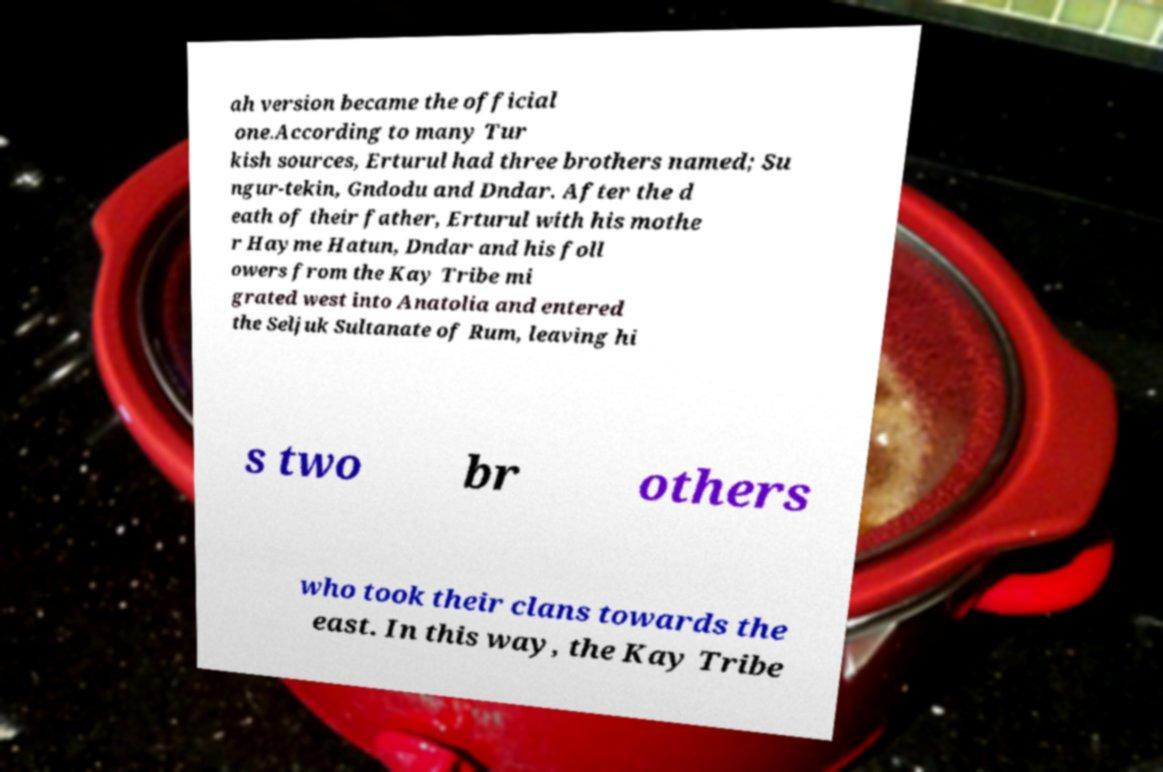Can you accurately transcribe the text from the provided image for me? ah version became the official one.According to many Tur kish sources, Erturul had three brothers named; Su ngur-tekin, Gndodu and Dndar. After the d eath of their father, Erturul with his mothe r Hayme Hatun, Dndar and his foll owers from the Kay Tribe mi grated west into Anatolia and entered the Seljuk Sultanate of Rum, leaving hi s two br others who took their clans towards the east. In this way, the Kay Tribe 